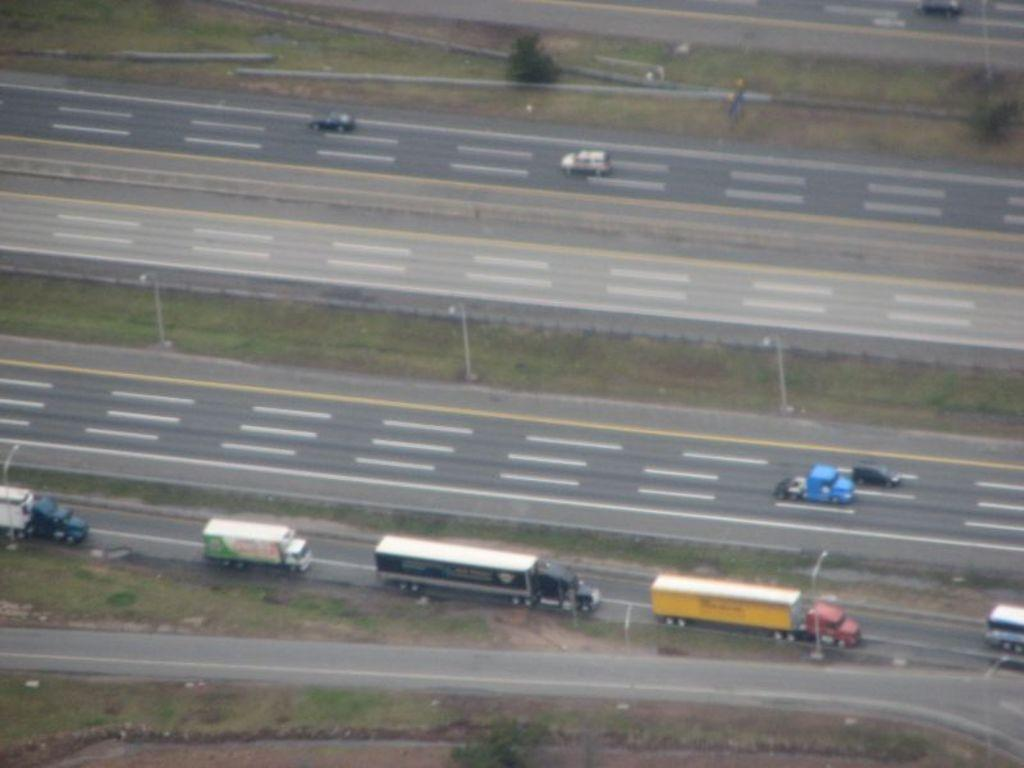What can be seen on the road in the image? There are vehicles on the road in the image. What structures are present alongside the road? There are light poles in the image. What type of vegetation is visible in the background of the image? There are trees in the background of the image. What is the color of the trees in the image? The trees are green in color. What type of brush is being used to paint the hall in the image? There is no mention of a brush, painting, or hall in the image. 